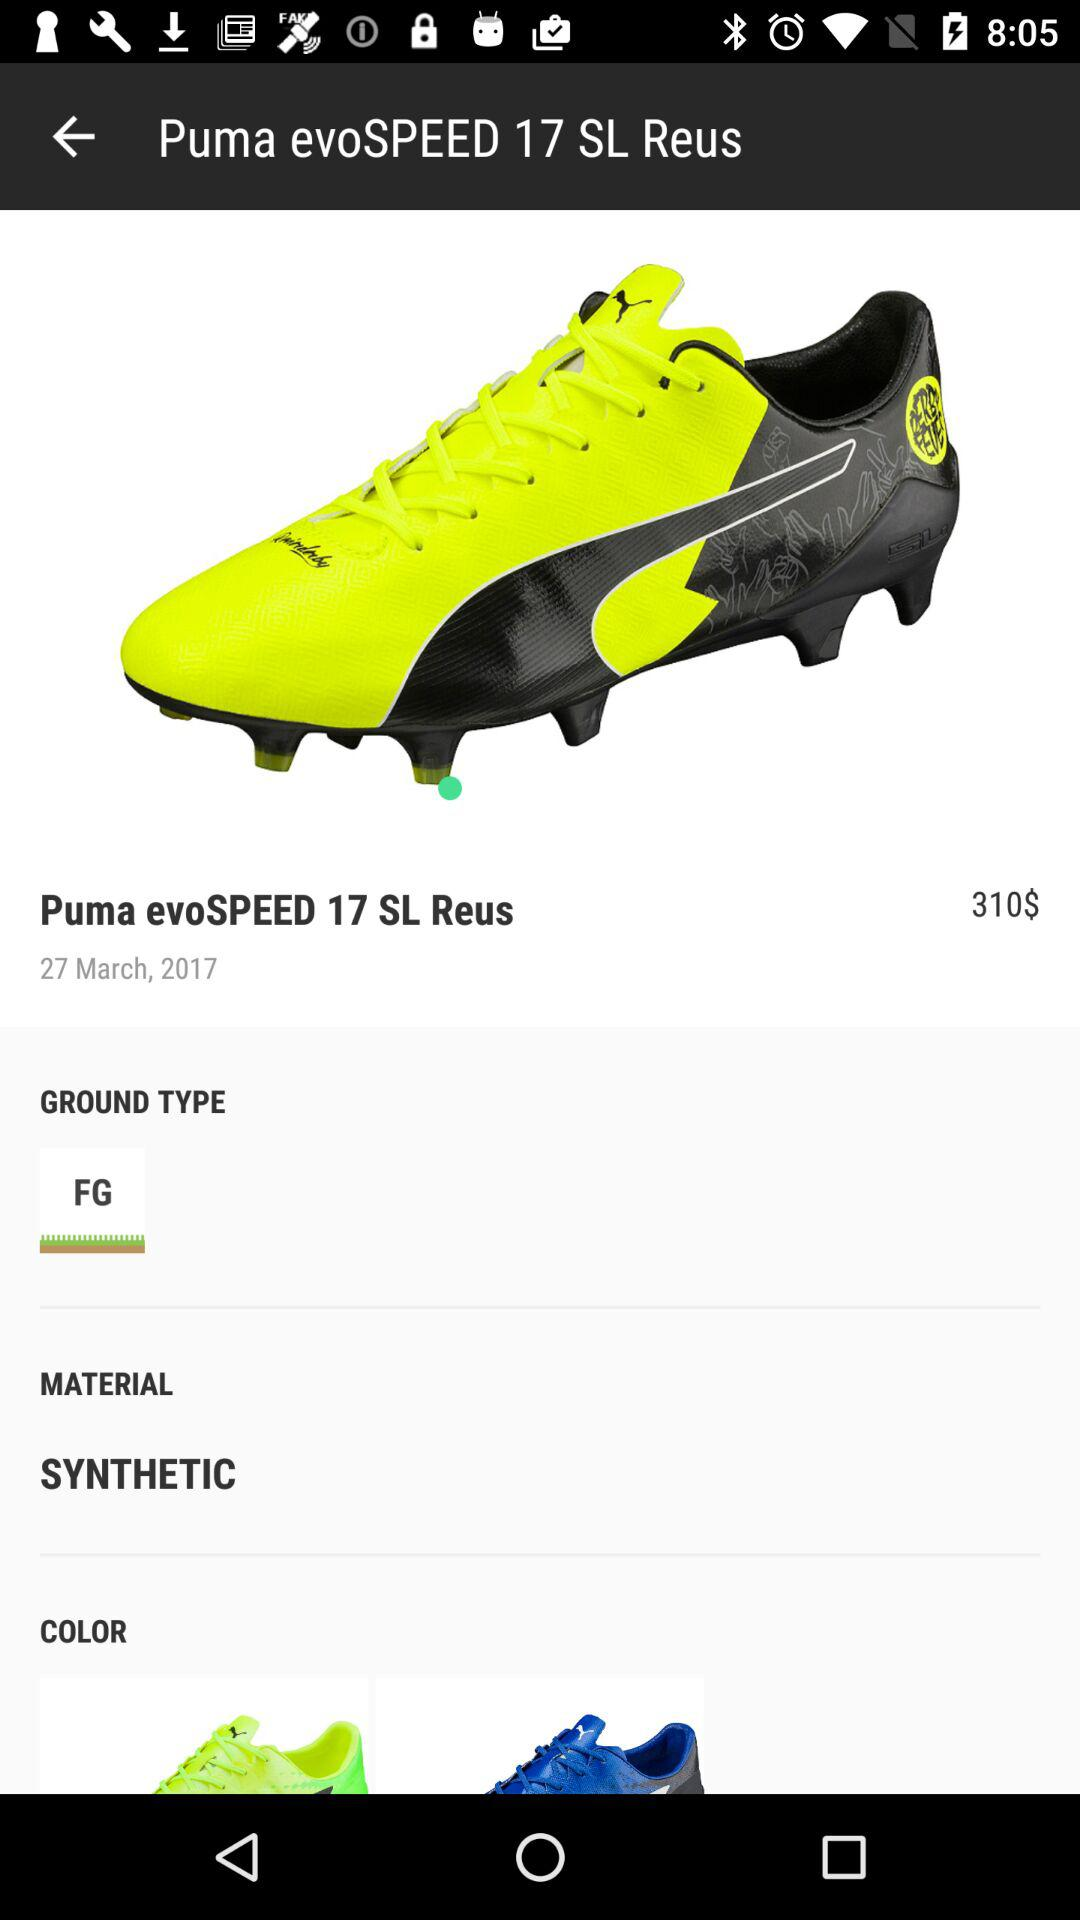What is the name of the shoe? The name of the shoe is "Puma evoSPEED 17 SL Reus". 